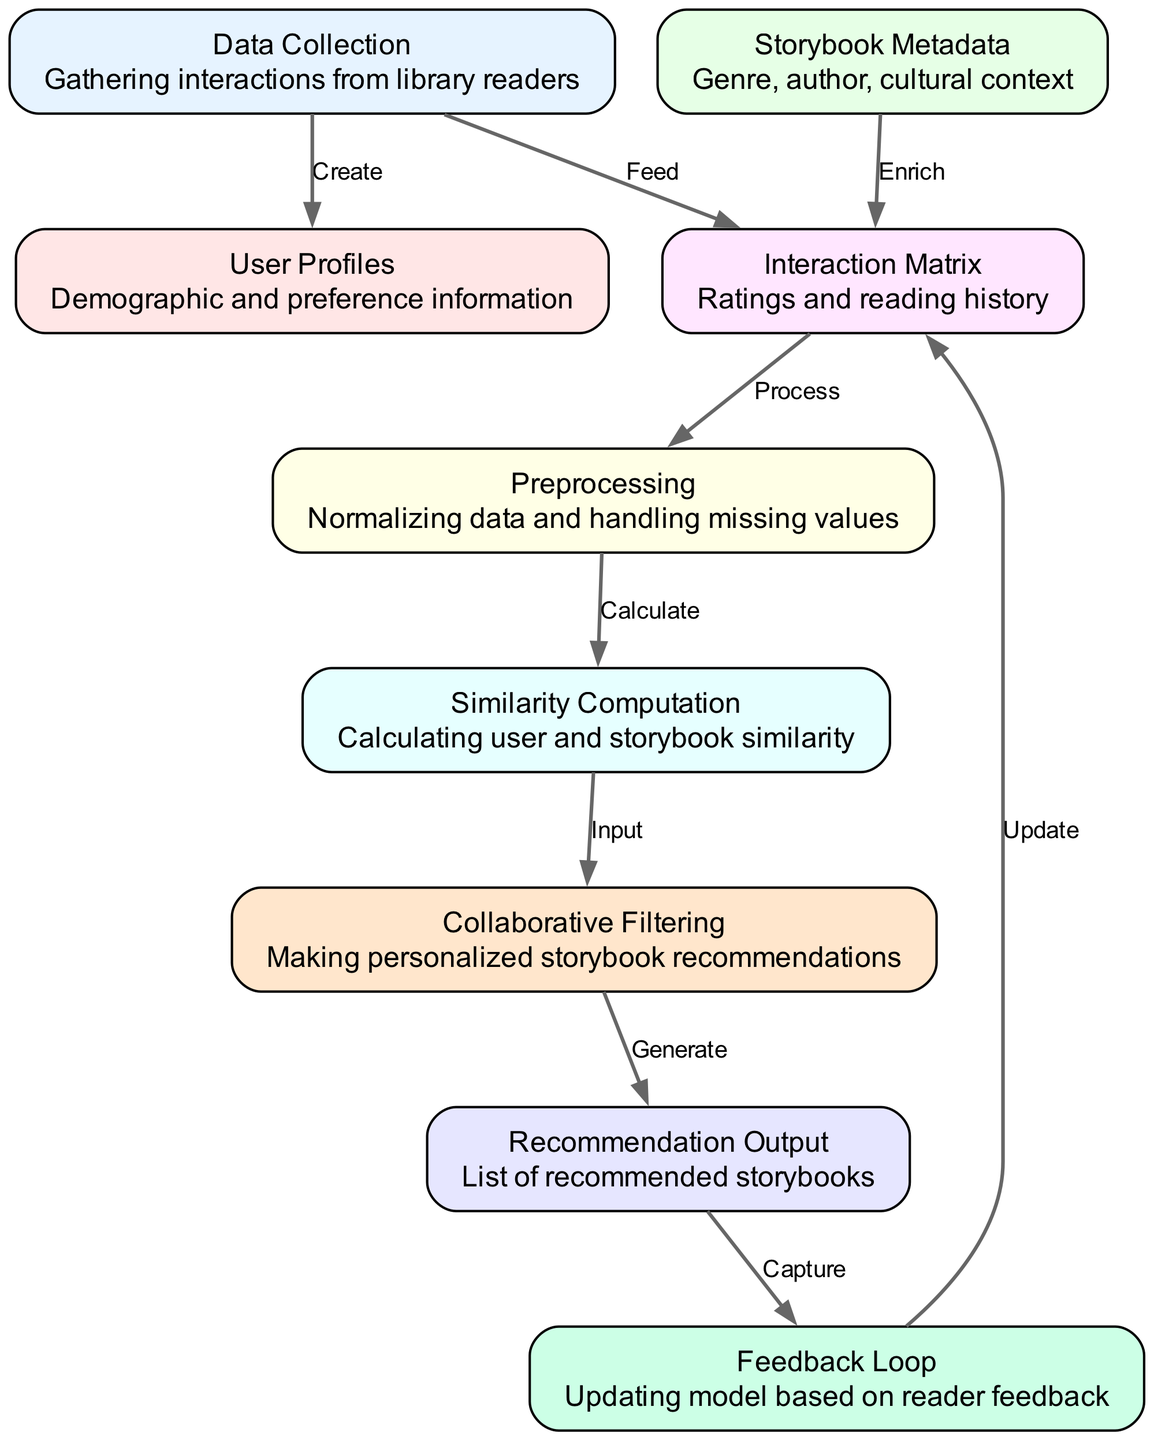What is the first step in the diagram? The first step is 'Data Collection', which involves gathering interactions from library readers. This is the starting point that feeds into the next steps in the recommendation process.
Answer: Data Collection How many nodes are present in the diagram? By counting each unique labeled box, we identify that there are nine distinct nodes in the diagram.
Answer: Nine What type of information is contained in 'User Profiles'? 'User Profiles' contains demographic and preference information about the library readers. This is essential for tailoring recommendations based on the readers' backgrounds and interests.
Answer: Demographic and preference information Which node is directly connected to 'Interaction Matrix'? The nodes directly connected to 'Interaction Matrix' are 'Data Collection', which feeds into it, and 'Preprocessing', which processes it. This shows a flow from data sources into the matrix used for recommendations.
Answer: Data Collection and Preprocessing What does the 'Feedback Loop' do in the diagram? The 'Feedback Loop' updates the 'Interaction Matrix' based on reader feedback about the recommendations generated, allowing the model to improve future recommendations.
Answer: Updating model based on reader feedback How does 'Similarity Computation' relate to 'Collaborative Filtering'? 'Similarity Computation' provides calculated user and storybook similarity as input for 'Collaborative Filtering', enabling the system to base recommendations on the identified similarities between users and storybooks.
Answer: Input Which node enriches the 'Interaction Matrix'? The 'storybook_metadata' node enriches the 'Interaction Matrix' by adding relevant information about the stories like genre, author, and cultural context, giving more depth for recommendations.
Answer: Storybook Metadata What is the final output of the diagram? The final output of the diagram is a list of recommended storybooks for the library readers based on the collaborative filtering process. This output is essential for delivering personalized reading suggestions.
Answer: List of recommended storybooks What process occurs after 'Recommendation Output'? After the 'Recommendation Output', a 'Feedback Loop' captures any reader feedback that can be used to refine and improve the recommendation model. This shows the iterative nature of the recommendation system based on user interactions.
Answer: Capture 